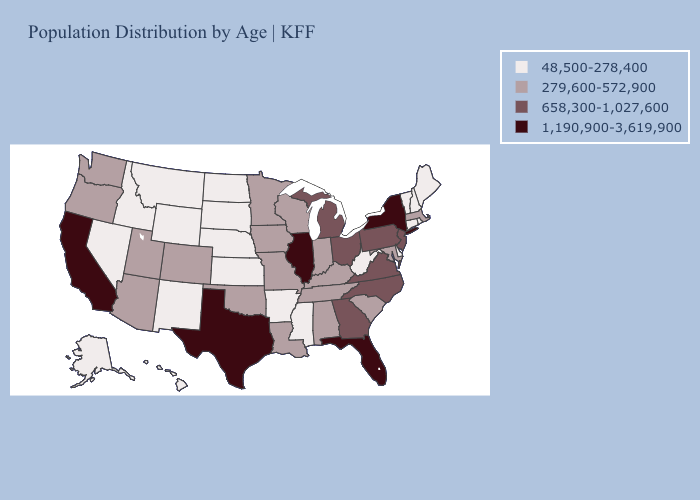Which states have the lowest value in the Northeast?
Write a very short answer. Connecticut, Maine, New Hampshire, Rhode Island, Vermont. Name the states that have a value in the range 1,190,900-3,619,900?
Quick response, please. California, Florida, Illinois, New York, Texas. Name the states that have a value in the range 1,190,900-3,619,900?
Give a very brief answer. California, Florida, Illinois, New York, Texas. What is the value of Arizona?
Write a very short answer. 279,600-572,900. Does Hawaii have a lower value than Nebraska?
Write a very short answer. No. Which states hav the highest value in the West?
Give a very brief answer. California. Name the states that have a value in the range 48,500-278,400?
Write a very short answer. Alaska, Arkansas, Connecticut, Delaware, Hawaii, Idaho, Kansas, Maine, Mississippi, Montana, Nebraska, Nevada, New Hampshire, New Mexico, North Dakota, Rhode Island, South Dakota, Vermont, West Virginia, Wyoming. Name the states that have a value in the range 658,300-1,027,600?
Be succinct. Georgia, Michigan, New Jersey, North Carolina, Ohio, Pennsylvania, Virginia. What is the lowest value in states that border Wyoming?
Give a very brief answer. 48,500-278,400. Name the states that have a value in the range 279,600-572,900?
Be succinct. Alabama, Arizona, Colorado, Indiana, Iowa, Kentucky, Louisiana, Maryland, Massachusetts, Minnesota, Missouri, Oklahoma, Oregon, South Carolina, Tennessee, Utah, Washington, Wisconsin. Name the states that have a value in the range 1,190,900-3,619,900?
Keep it brief. California, Florida, Illinois, New York, Texas. Name the states that have a value in the range 279,600-572,900?
Concise answer only. Alabama, Arizona, Colorado, Indiana, Iowa, Kentucky, Louisiana, Maryland, Massachusetts, Minnesota, Missouri, Oklahoma, Oregon, South Carolina, Tennessee, Utah, Washington, Wisconsin. What is the value of Utah?
Answer briefly. 279,600-572,900. Name the states that have a value in the range 1,190,900-3,619,900?
Give a very brief answer. California, Florida, Illinois, New York, Texas. What is the lowest value in the USA?
Concise answer only. 48,500-278,400. 